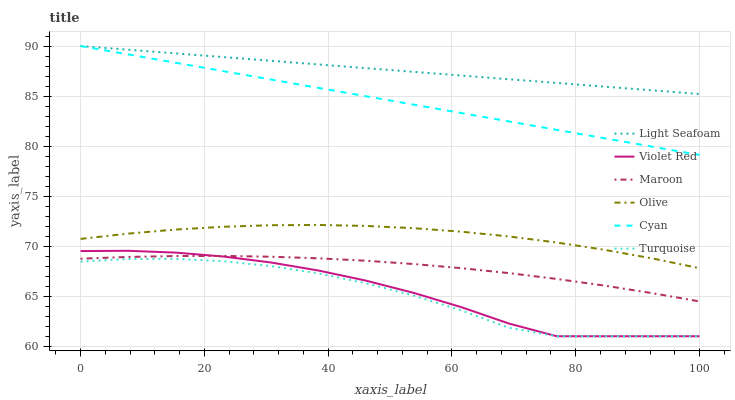Does Maroon have the minimum area under the curve?
Answer yes or no. No. Does Maroon have the maximum area under the curve?
Answer yes or no. No. Is Maroon the smoothest?
Answer yes or no. No. Is Maroon the roughest?
Answer yes or no. No. Does Maroon have the lowest value?
Answer yes or no. No. Does Maroon have the highest value?
Answer yes or no. No. Is Turquoise less than Maroon?
Answer yes or no. Yes. Is Olive greater than Violet Red?
Answer yes or no. Yes. Does Turquoise intersect Maroon?
Answer yes or no. No. 